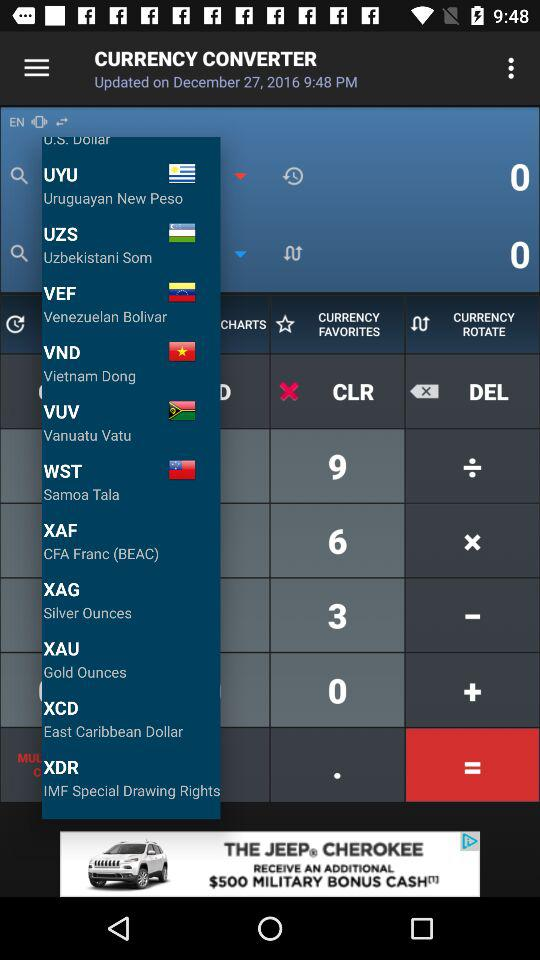What is the currency of Vietnam? The currency of Vietnam is "Vietnam Dong". 